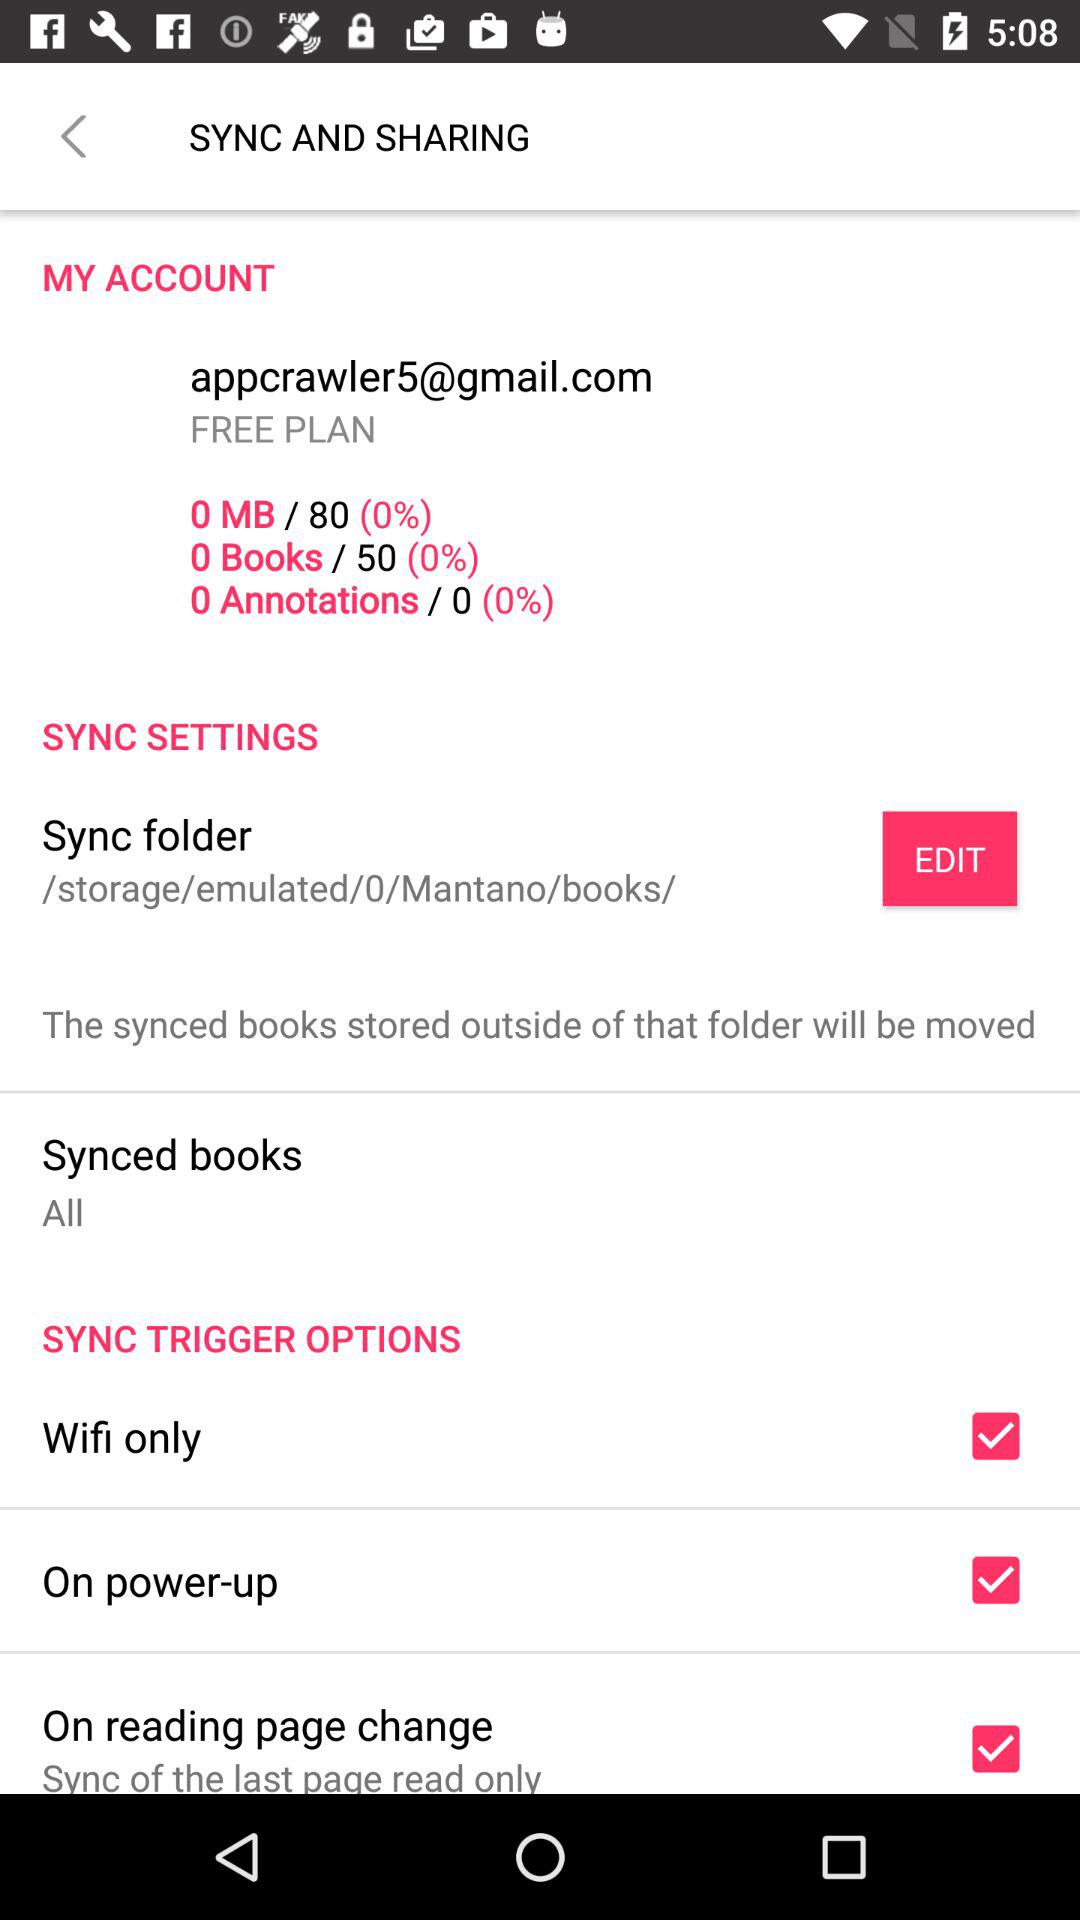How many options are there for sync trigger?
Answer the question using a single word or phrase. 3 